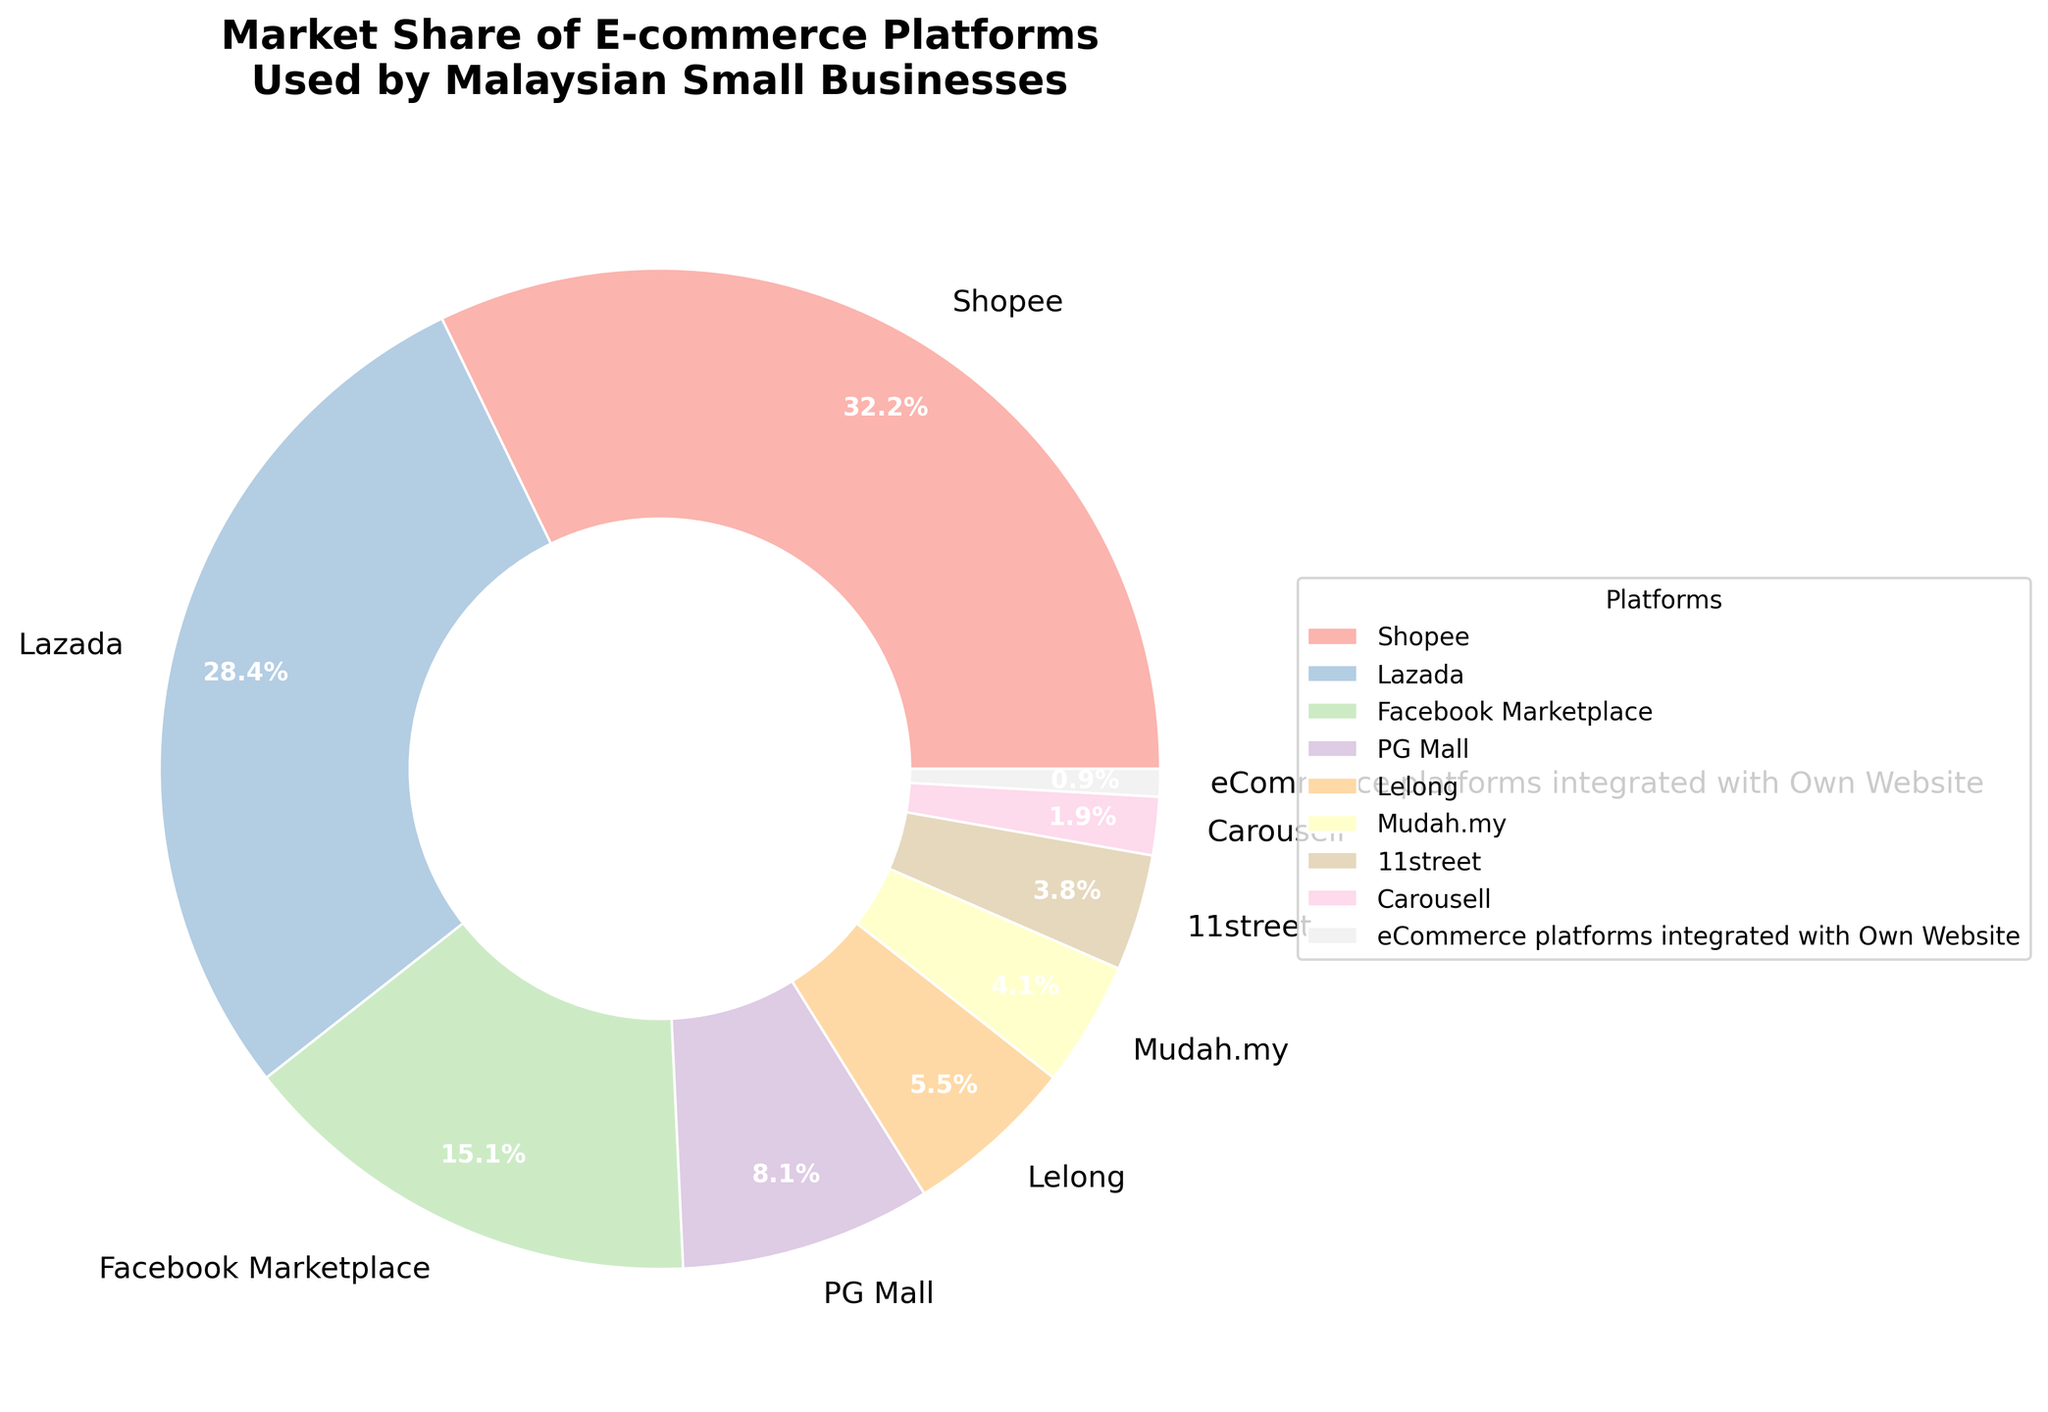What percentage of Malaysian small businesses use Shopee as their e-commerce platform? Refer to the data shown on the chart where Shopee's market share is indicated.
Answer: 32.5% Which platform has a higher market share: PG Mall or Lelong? Compare the market share slice size or the labeled percentages for PG Mall and Lelong. PG Mall has 8.2%, and Lelong has 5.6%.
Answer: PG Mall What is the combined market share of Facebook Marketplace, PG Mall, and Carousell? Add the individual market shares: 15.3% (Facebook Marketplace) + 8.2% (PG Mall) + 1.9% (Carousell) = 25.4%
Answer: 25.4% By how much does Shopee's market share exceed Mudah.my's market share? Subtract Mudah.my's market share from Shopee's market share: 32.5% - 4.1% = 28.4%
Answer: 28.4% How many platforms have a market share of less than 5%? Count the number of platforms with a percentage label less than 5%: Mudah.my (4.1%), 11street (3.8%), Carousell (1.9%), eCommerce platforms integrated with Own Website (0.9%).
Answer: 4 What is the difference in market share between the top two e-commerce platforms used by Malaysian small businesses? Compare the market shares of Shopee (32.5%) and Lazada (28.7%) and subtract the smaller value from the larger one: 32.5% - 28.7% = 3.8%
Answer: 3.8% Which platform's market share is closest to 10%? Identify the platform with a market share closest to 10%. PG Mall has a market share of 8.2%, which is closest to 10%.
Answer: PG Mall What proportion of the total market share is held by the bottom three platforms? Add the market shares of the bottom three platforms: Carousell (1.9%) + eCommerce platforms integrated with Own Website (0.9%) + 11street (3.8%) = 6.6%
Answer: 6.6% What is the visual difference between the market shares of Lazada and Facebook Marketplace? Observe the pie chart slices for Lazada and Facebook Marketplace. Lazada's slice is significantly larger compared to Facebook Marketplace. Lazada's market share is 28.7%, while Facebook Marketplace's is 15.3%.
Answer: Lazada’s slice is larger Which platform has the smallest market share, and what is it? Look at the smallest slice or the label with the smallest percentage. eCommerce platforms integrated with Own Website has the smallest market share at 0.9%.
Answer: eCommerce platforms integrated with Own Website, 0.9% 